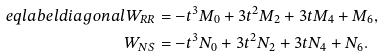Convert formula to latex. <formula><loc_0><loc_0><loc_500><loc_500>\ e q l a b e l { d i a g o n a l } W _ { R R } & = - t ^ { 3 } M _ { 0 } + 3 t ^ { 2 } M _ { 2 } + 3 t M _ { 4 } + M _ { 6 } , \\ W _ { N S } & = - t ^ { 3 } N _ { 0 } + 3 t ^ { 2 } N _ { 2 } + 3 t N _ { 4 } + N _ { 6 } .</formula> 